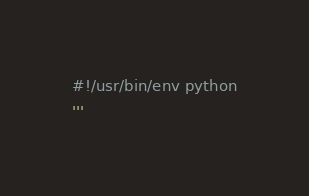Convert code to text. <code><loc_0><loc_0><loc_500><loc_500><_Python_>#!/usr/bin/env python
'''</code> 